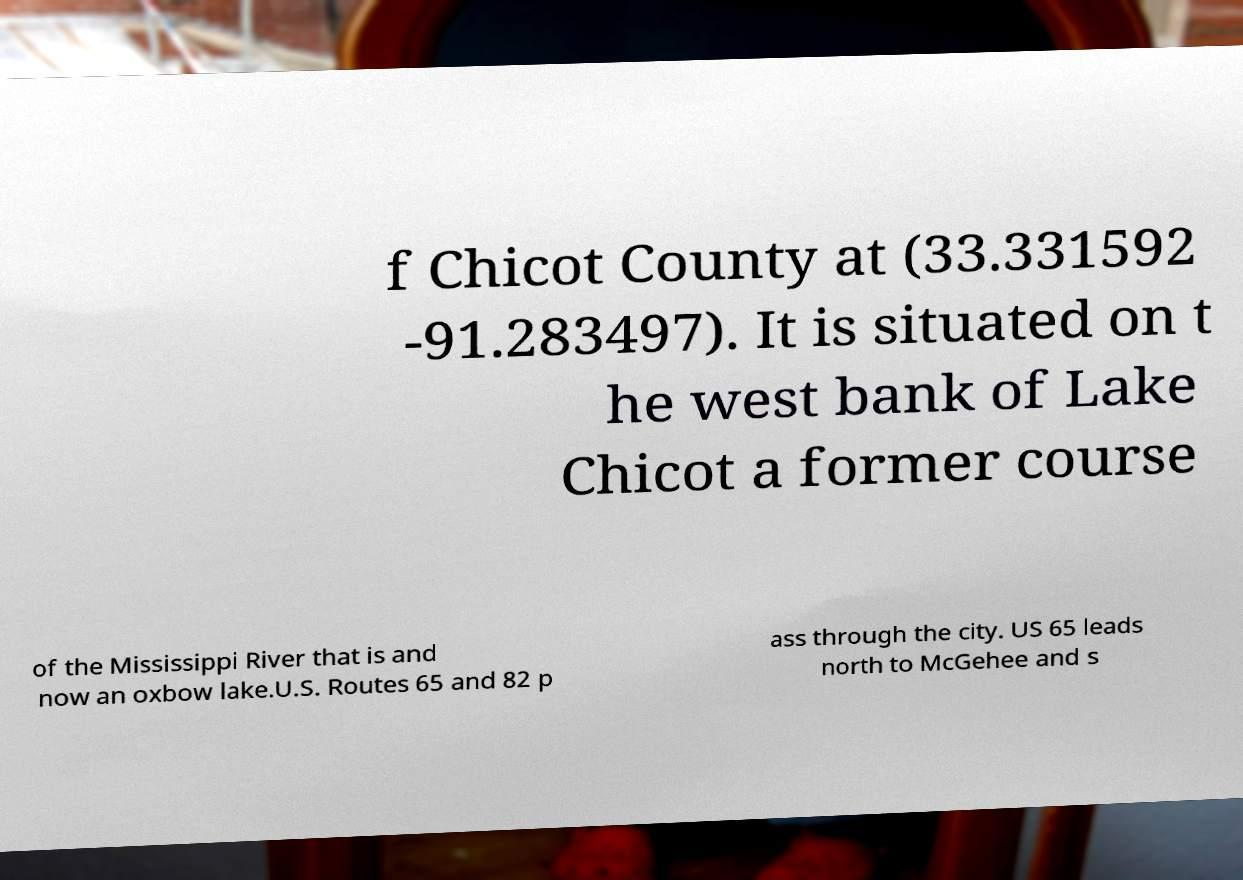Can you accurately transcribe the text from the provided image for me? f Chicot County at (33.331592 -91.283497). It is situated on t he west bank of Lake Chicot a former course of the Mississippi River that is and now an oxbow lake.U.S. Routes 65 and 82 p ass through the city. US 65 leads north to McGehee and s 